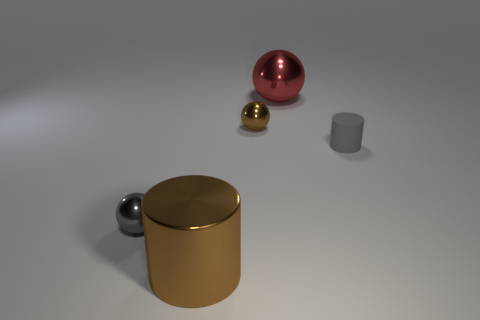Subtract all small spheres. How many spheres are left? 1 Add 2 big brown shiny things. How many objects exist? 7 Add 4 tiny gray matte cylinders. How many tiny gray matte cylinders are left? 5 Add 5 tiny brown balls. How many tiny brown balls exist? 6 Subtract all gray balls. How many balls are left? 2 Subtract 0 purple cylinders. How many objects are left? 5 Subtract all spheres. How many objects are left? 2 Subtract 2 cylinders. How many cylinders are left? 0 Subtract all red cylinders. Subtract all red balls. How many cylinders are left? 2 Subtract all green cubes. How many brown cylinders are left? 1 